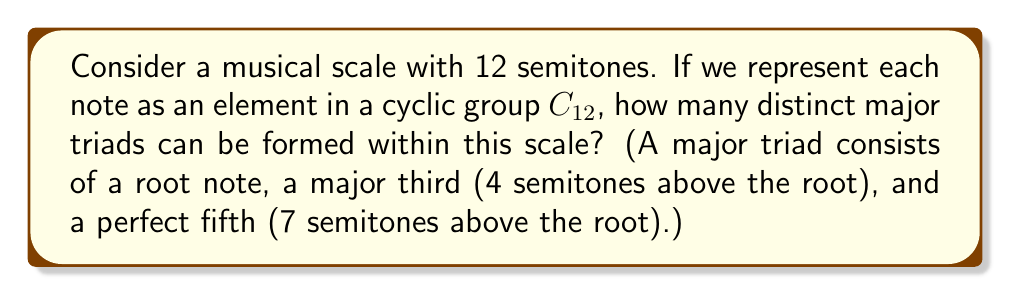Give your solution to this math problem. Let's approach this step-by-step using group theory:

1) First, we represent our 12-tone scale as the cyclic group $C_{12} = \{0, 1, 2, ..., 11\}$, where each number represents a semitone above the root note (0).

2) A major triad consists of three notes: root, major third (4 semitones above), and perfect fifth (7 semitones above). In our group notation, this is represented as the set $\{x, x+4, x+7\}$ where $x$ is the root note and all operations are performed modulo 12.

3) To find how many distinct triads exist, we need to determine how many unique sets of this form we can create within $C_{12}$.

4) We can generate all possible triads by applying the group action of $C_{12}$ on the set $\{0, 4, 7\}$ (C major triad):

   $\{0, 4, 7\}$, $\{1, 5, 8\}$, $\{2, 6, 9\}$, $\{3, 7, 10\}$, $\{4, 8, 11\}$, $\{5, 9, 0\}$,
   $\{6, 10, 1\}$, $\{7, 11, 2\}$, $\{8, 0, 3\}$, $\{9, 1, 4\}$, $\{10, 2, 5\}$, $\{11, 3, 6\}$

5) Each of these 12 sets represents a unique major triad in the 12-tone scale.

6) Therefore, there are 12 distinct major triads in the 12-tone scale.

This result aligns with the musical concept that there is one major triad for each of the 12 possible root notes in the chromatic scale.
Answer: 12 